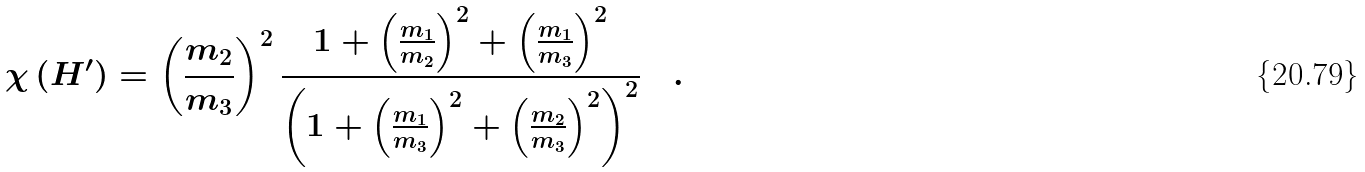Convert formula to latex. <formula><loc_0><loc_0><loc_500><loc_500>\chi \left ( H ^ { \prime } \right ) = \left ( \frac { m _ { 2 } } { m _ { 3 } } \right ) ^ { 2 } \frac { 1 + \left ( \frac { m _ { 1 } } { m _ { 2 } } \right ) ^ { 2 } + \left ( \frac { m _ { 1 } } { m _ { 3 } } \right ) ^ { 2 } } { \left ( 1 + \left ( \frac { m _ { 1 } } { m _ { 3 } } \right ) ^ { 2 } + \left ( \frac { m _ { 2 } } { m _ { 3 } } \right ) ^ { 2 } \right ) ^ { 2 } } \quad .</formula> 